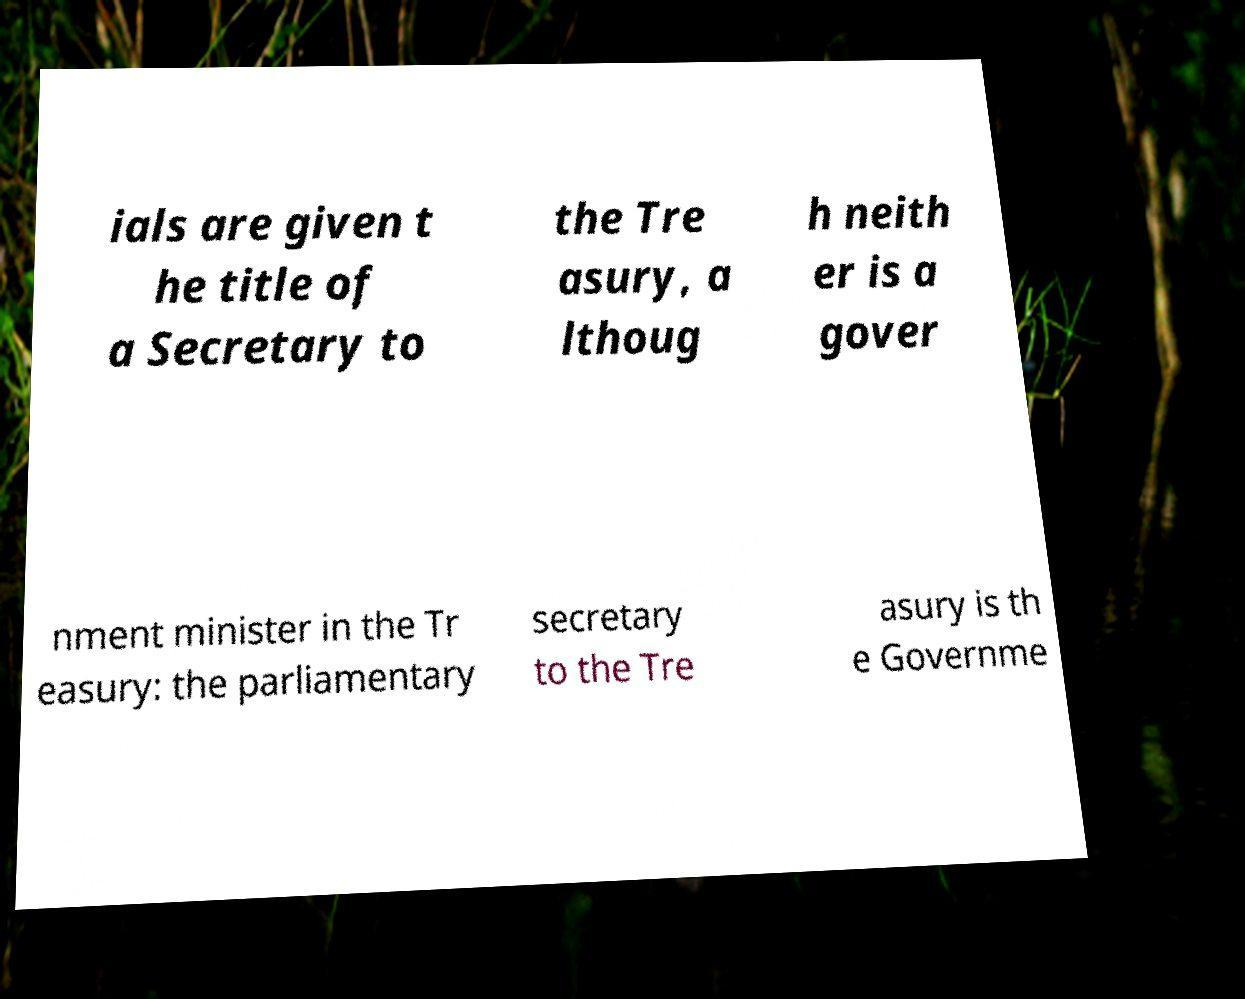For documentation purposes, I need the text within this image transcribed. Could you provide that? ials are given t he title of a Secretary to the Tre asury, a lthoug h neith er is a gover nment minister in the Tr easury: the parliamentary secretary to the Tre asury is th e Governme 